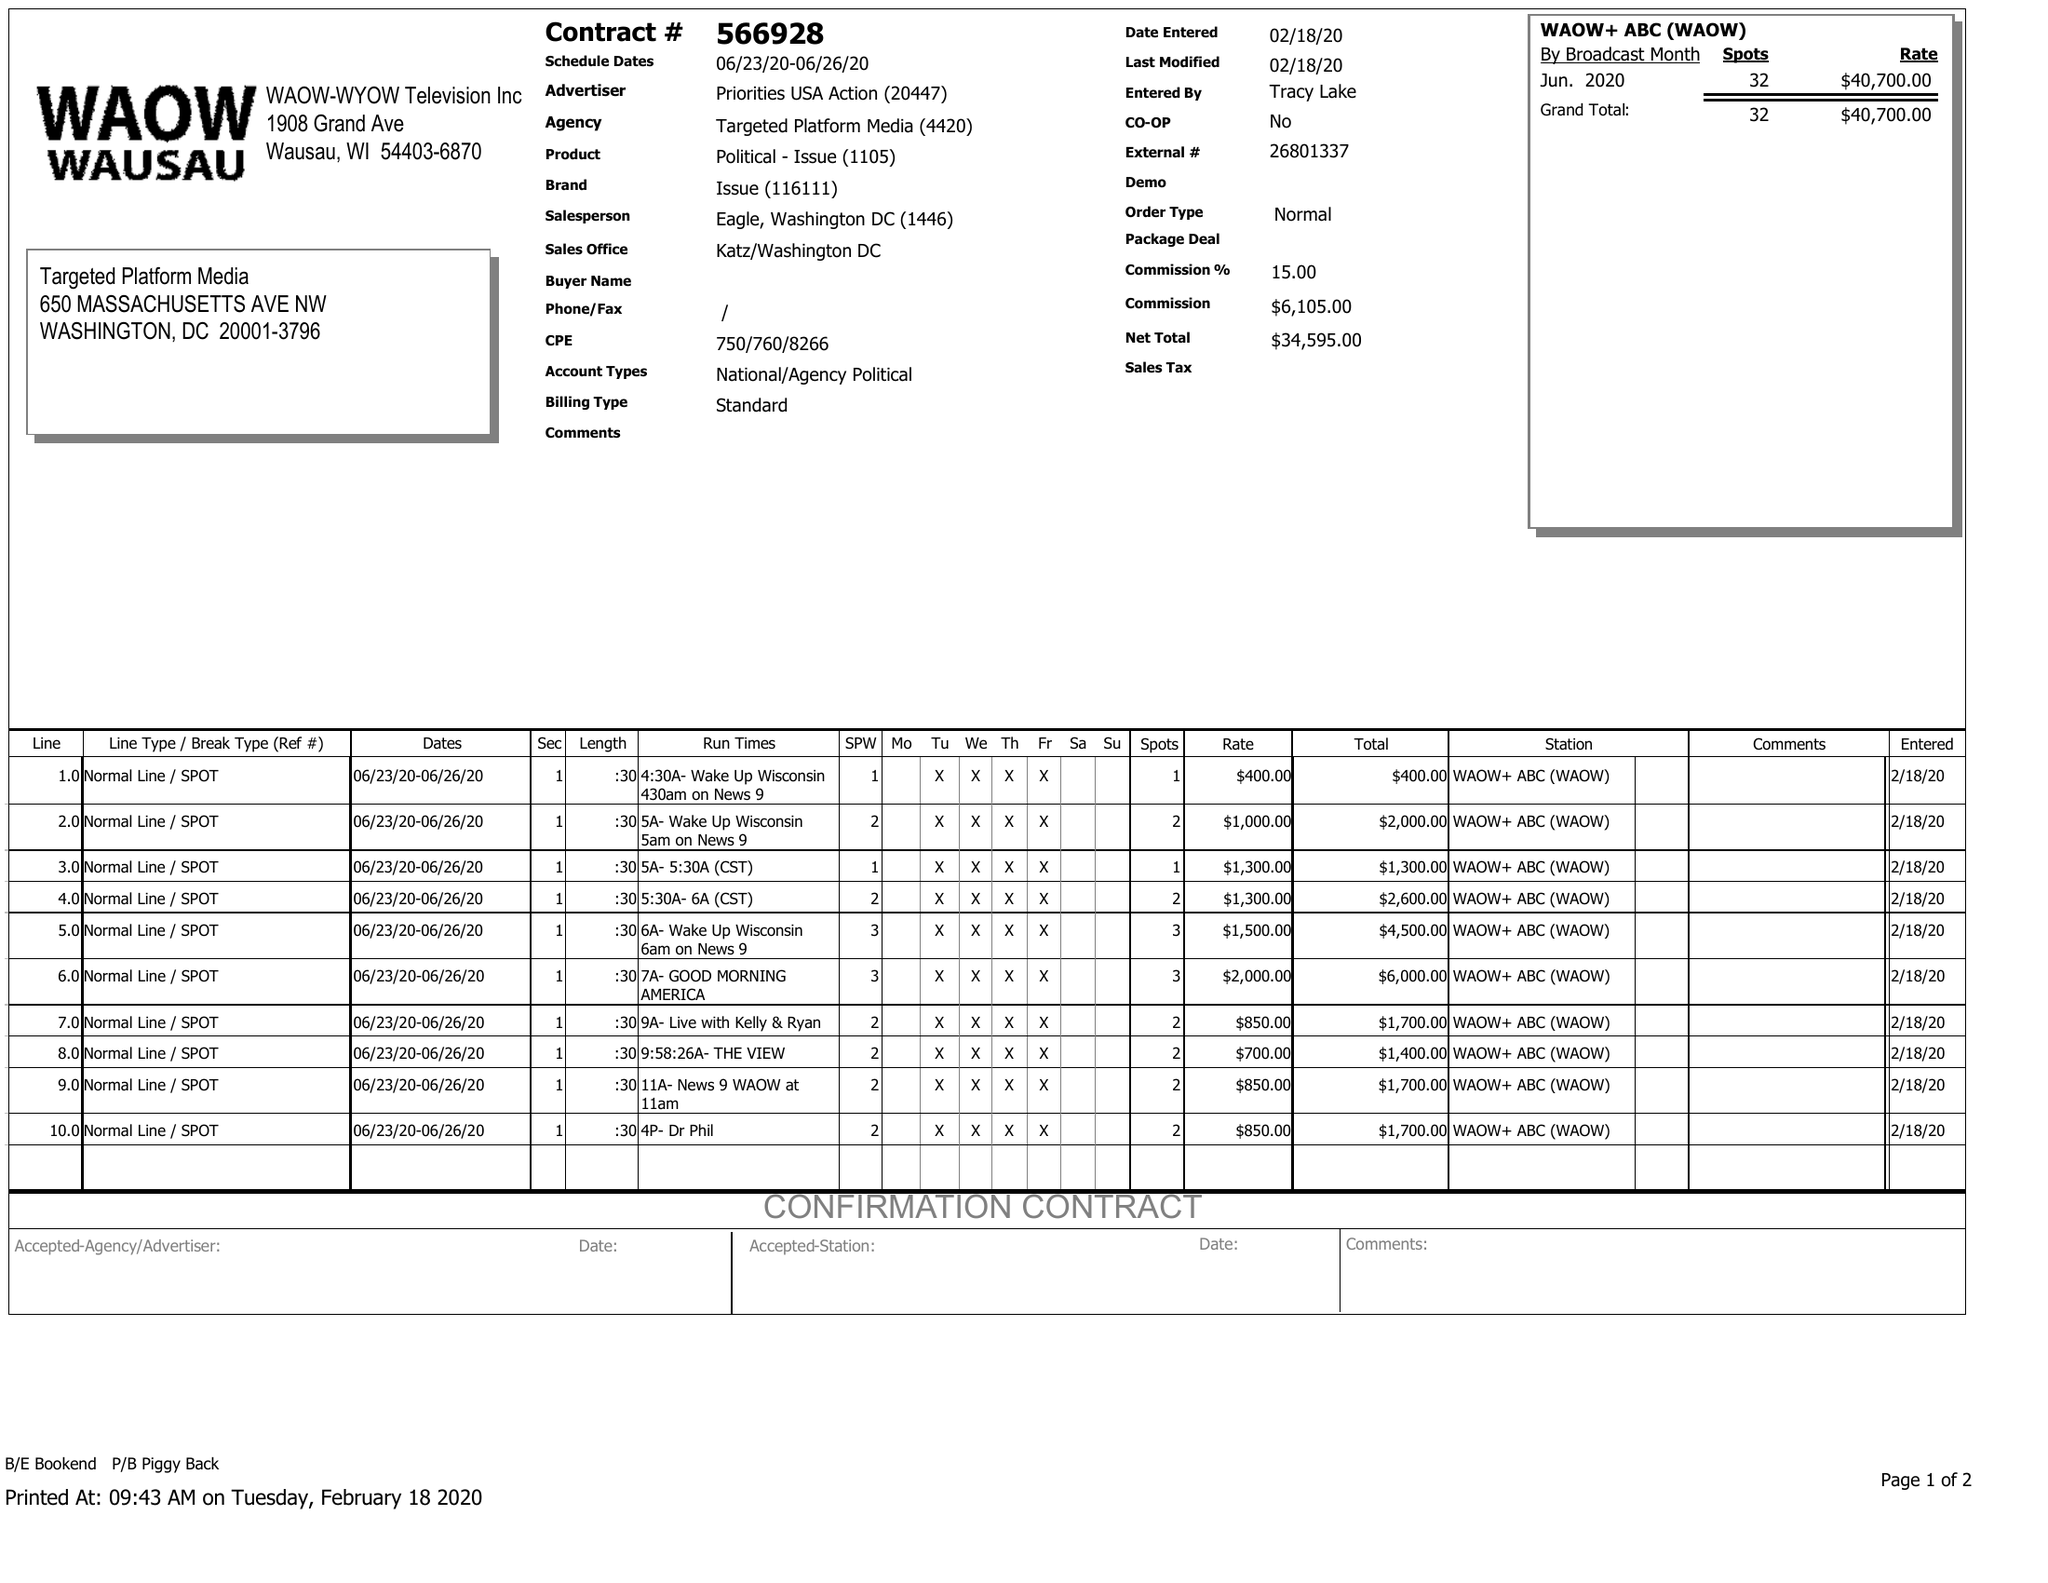What is the value for the contract_num?
Answer the question using a single word or phrase. 566928 